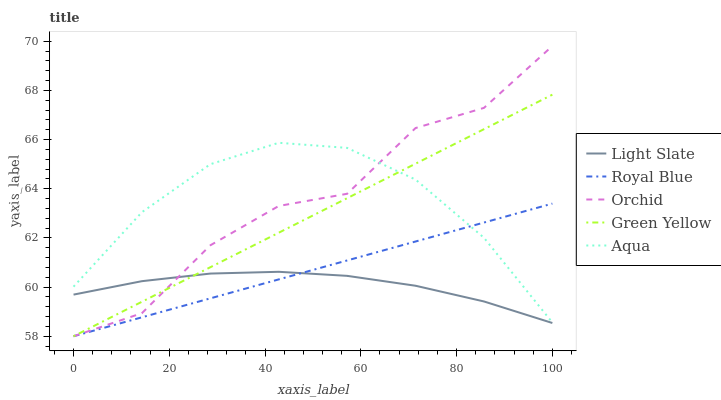Does Light Slate have the minimum area under the curve?
Answer yes or no. Yes. Does Orchid have the maximum area under the curve?
Answer yes or no. Yes. Does Royal Blue have the minimum area under the curve?
Answer yes or no. No. Does Royal Blue have the maximum area under the curve?
Answer yes or no. No. Is Royal Blue the smoothest?
Answer yes or no. Yes. Is Orchid the roughest?
Answer yes or no. Yes. Is Green Yellow the smoothest?
Answer yes or no. No. Is Green Yellow the roughest?
Answer yes or no. No. Does Royal Blue have the lowest value?
Answer yes or no. Yes. Does Aqua have the lowest value?
Answer yes or no. No. Does Orchid have the highest value?
Answer yes or no. Yes. Does Royal Blue have the highest value?
Answer yes or no. No. Is Light Slate less than Aqua?
Answer yes or no. Yes. Is Aqua greater than Light Slate?
Answer yes or no. Yes. Does Royal Blue intersect Aqua?
Answer yes or no. Yes. Is Royal Blue less than Aqua?
Answer yes or no. No. Is Royal Blue greater than Aqua?
Answer yes or no. No. Does Light Slate intersect Aqua?
Answer yes or no. No. 